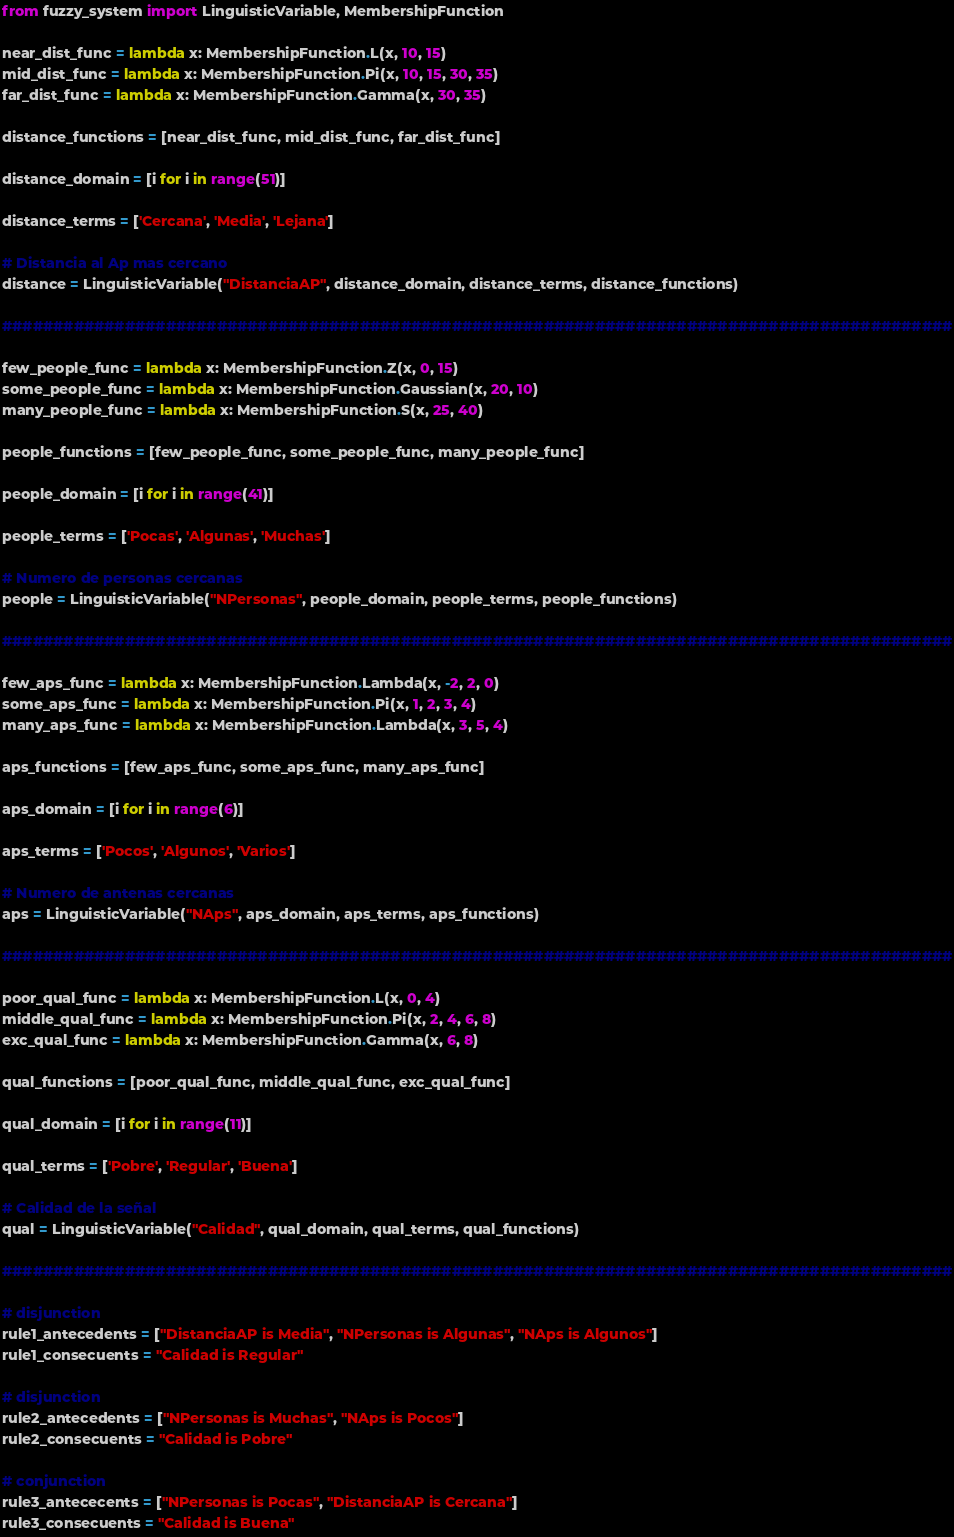Convert code to text. <code><loc_0><loc_0><loc_500><loc_500><_Python_>from fuzzy_system import LinguisticVariable, MembershipFunction

near_dist_func = lambda x: MembershipFunction.L(x, 10, 15)
mid_dist_func = lambda x: MembershipFunction.Pi(x, 10, 15, 30, 35)
far_dist_func = lambda x: MembershipFunction.Gamma(x, 30, 35)

distance_functions = [near_dist_func, mid_dist_func, far_dist_func]

distance_domain = [i for i in range(51)]

distance_terms = ['Cercana', 'Media', 'Lejana']

# Distancia al Ap mas cercano
distance = LinguisticVariable("DistanciaAP", distance_domain, distance_terms, distance_functions)

#############################################################################################

few_people_func = lambda x: MembershipFunction.Z(x, 0, 15)
some_people_func = lambda x: MembershipFunction.Gaussian(x, 20, 10)
many_people_func = lambda x: MembershipFunction.S(x, 25, 40)

people_functions = [few_people_func, some_people_func, many_people_func]

people_domain = [i for i in range(41)]

people_terms = ['Pocas', 'Algunas', 'Muchas']

# Numero de personas cercanas
people = LinguisticVariable("NPersonas", people_domain, people_terms, people_functions)

#############################################################################################

few_aps_func = lambda x: MembershipFunction.Lambda(x, -2, 2, 0)
some_aps_func = lambda x: MembershipFunction.Pi(x, 1, 2, 3, 4)
many_aps_func = lambda x: MembershipFunction.Lambda(x, 3, 5, 4)

aps_functions = [few_aps_func, some_aps_func, many_aps_func]

aps_domain = [i for i in range(6)]

aps_terms = ['Pocos', 'Algunos', 'Varios']

# Numero de antenas cercanas
aps = LinguisticVariable("NAps", aps_domain, aps_terms, aps_functions)

#############################################################################################

poor_qual_func = lambda x: MembershipFunction.L(x, 0, 4)
middle_qual_func = lambda x: MembershipFunction.Pi(x, 2, 4, 6, 8)
exc_qual_func = lambda x: MembershipFunction.Gamma(x, 6, 8)

qual_functions = [poor_qual_func, middle_qual_func, exc_qual_func]

qual_domain = [i for i in range(11)]

qual_terms = ['Pobre', 'Regular', 'Buena']

# Calidad de la señal
qual = LinguisticVariable("Calidad", qual_domain, qual_terms, qual_functions)

#############################################################################################

# disjunction
rule1_antecedents = ["DistanciaAP is Media", "NPersonas is Algunas", "NAps is Algunos"]
rule1_consecuents = "Calidad is Regular"

# disjunction
rule2_antecedents = ["NPersonas is Muchas", "NAps is Pocos"]
rule2_consecuents = "Calidad is Pobre"

# conjunction
rule3_antececents = ["NPersonas is Pocas", "DistanciaAP is Cercana"]
rule3_consecuents = "Calidad is Buena"</code> 